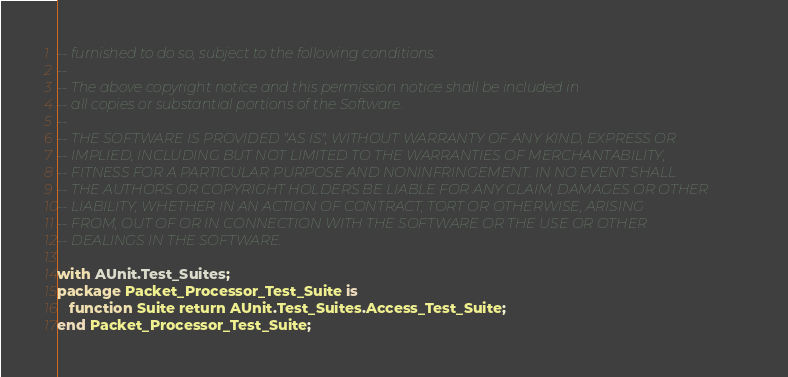<code> <loc_0><loc_0><loc_500><loc_500><_Ada_>-- furnished to do so, subject to the following conditions:
--
-- The above copyright notice and this permission notice shall be included in
-- all copies or substantial portions of the Software.
--
-- THE SOFTWARE IS PROVIDED "AS IS", WITHOUT WARRANTY OF ANY KIND, EXPRESS OR
-- IMPLIED, INCLUDING BUT NOT LIMITED TO THE WARRANTIES OF MERCHANTABILITY,
-- FITNESS FOR A PARTICULAR PURPOSE AND NONINFRINGEMENT. IN NO EVENT SHALL
-- THE AUTHORS OR COPYRIGHT HOLDERS BE LIABLE FOR ANY CLAIM, DAMAGES OR OTHER
-- LIABILITY, WHETHER IN AN ACTION OF CONTRACT, TORT OR OTHERWISE, ARISING
-- FROM, OUT OF OR IN CONNECTION WITH THE SOFTWARE OR THE USE OR OTHER
-- DEALINGS IN THE SOFTWARE.

with AUnit.Test_Suites;
package Packet_Processor_Test_Suite is
   function Suite return AUnit.Test_Suites.Access_Test_Suite;
end Packet_Processor_Test_Suite;
</code> 